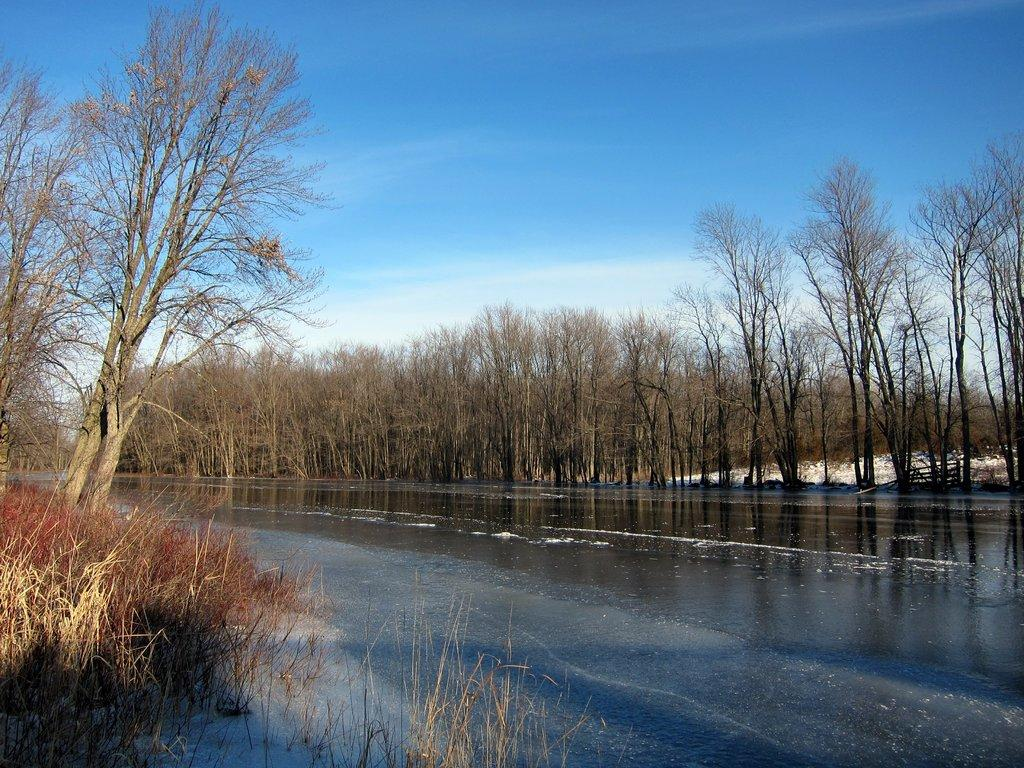What is visible in the image that is related to water? There is water visible in the image. What type of vegetation can be seen in the image? There are dried trees and dried grass in the image. What is visible in the sky in the image? There are clouds in the sky in the image. Can you see a rat swimming in the water in the image? There is no rat present in the image, and no swimming activity can be observed. What type of division is visible in the image? There is no division or separation of any kind visible in the image. 